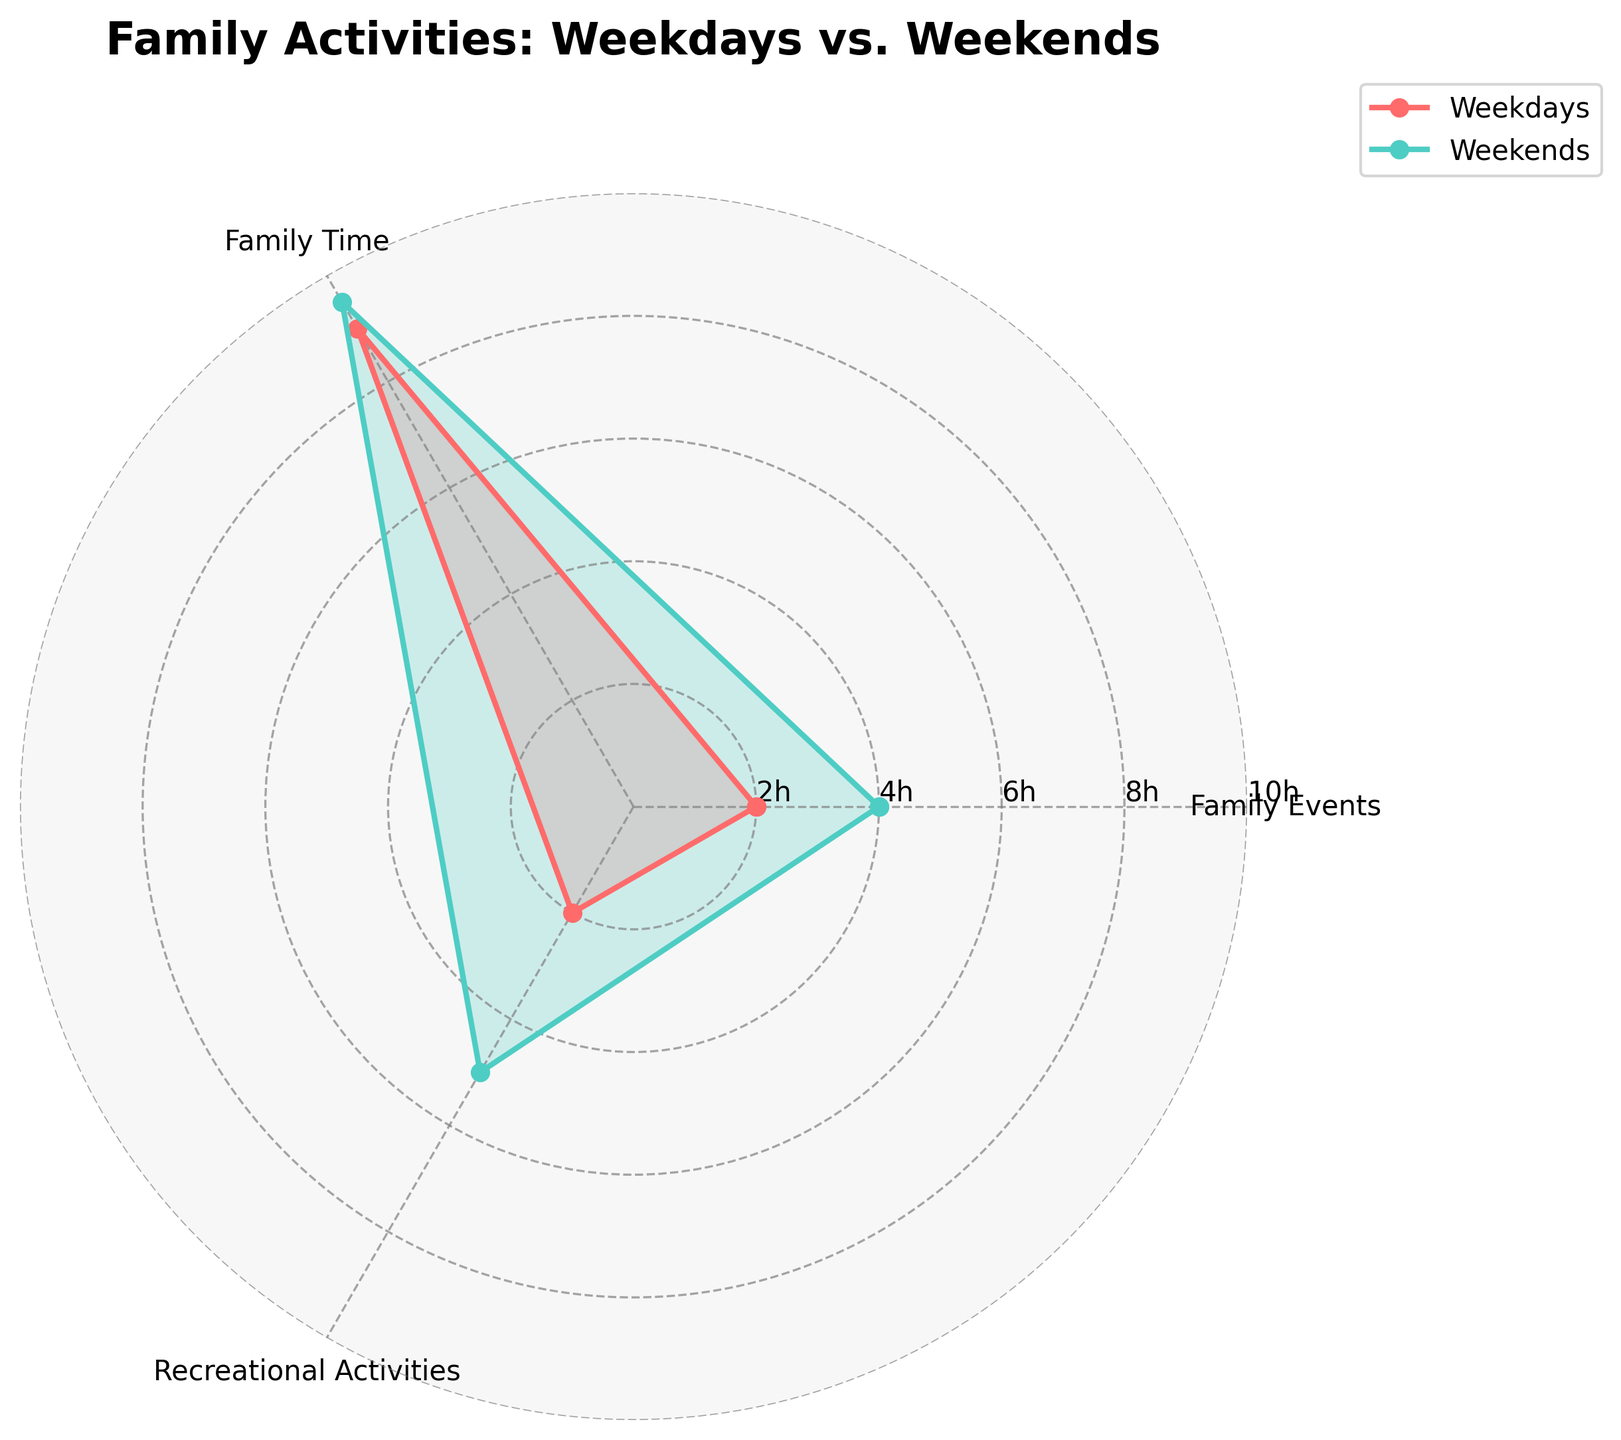Which day has more time spent on recreational activities? Weekends show 5 hours spent on recreational activities compared to 2 hours on weekdays, according to the radar chart.
Answer: Weekends How much more time is spent attending Hendrik's tennis matches on weekends compared to weekdays? Weekends show 4 hours spent attending tennis matches while weekdays have 2 hours. The difference is 4 - 2 = 2 hours.
Answer: 2 hours What is the total time spent on family time activities during weekends? Family time activities include meals together, babysitting grandchildren, and phone calls with grandchildren. These activities sum to 6 + 2 + 1.5 = 9.5 hours.
Answer: 9.5 hours Which category has the least difference in time spent between weekends and weekdays? Family Time has 9 hours on weekdays and 9.5 hours on weekends, showing only a 0.5-hour difference. The other categories show greater differences.
Answer: Family Time What is the ratio of time spent on family events to recreational activities on weekdays? Weekdays have 2 hours on family events and 2 hours on recreational activities, resulting in a ratio of 2:2, which simplifies to 1:1.
Answer: 1:1 On which days are there more hours spent going to the park? The radar chart indicates 2 hours spent going to the park on weekends versus 1 hour on weekdays, so more time is spent on weekends.
Answer: Weekends Is the total time spent on family activities higher on weekends compared to weekdays? Summing all the hours for weekends gives 4 (tennis matches) + 6 (meals together) + 2 (babysitting) + 1.5 (phone calls) + 2 (park) + 3 (outings) = 18.5 hours. For weekdays, it is 2 + 5 + 3 + 1 + 1 + 1 = 13 hours. 18.5 > 13, so weekends have more total hours.
Answer: Yes Which category shows the largest increase in time spent from weekdays to weekends? Recreational Activities increase from 2 hours on weekdays to 5 hours on weekends, an increase of 3 hours, compared to 2 hours in Family Events and 0.5 hours in Family Time.
Answer: Recreational Activities What is the average time spent on family events and family time during weekends? For weekends, family events have 4 hours, and family time has 9.5 hours. Average is (4 + 9.5) / 2 = 6.75 hours.
Answer: 6.75 hours 